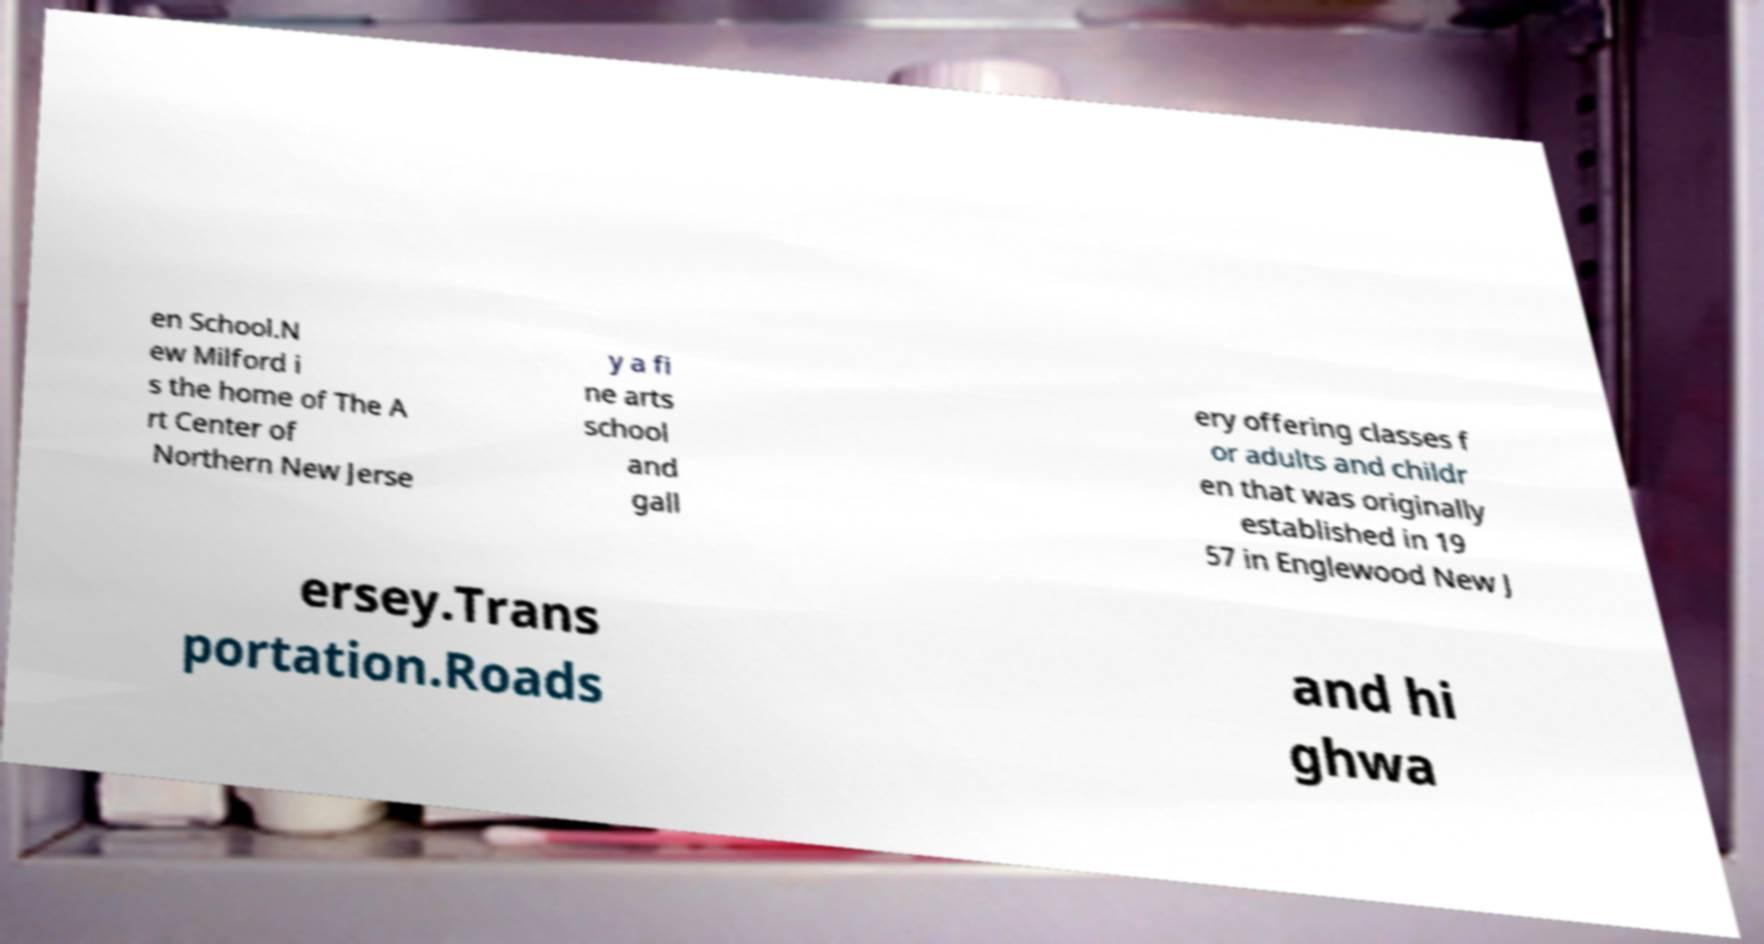Could you assist in decoding the text presented in this image and type it out clearly? en School.N ew Milford i s the home of The A rt Center of Northern New Jerse y a fi ne arts school and gall ery offering classes f or adults and childr en that was originally established in 19 57 in Englewood New J ersey.Trans portation.Roads and hi ghwa 